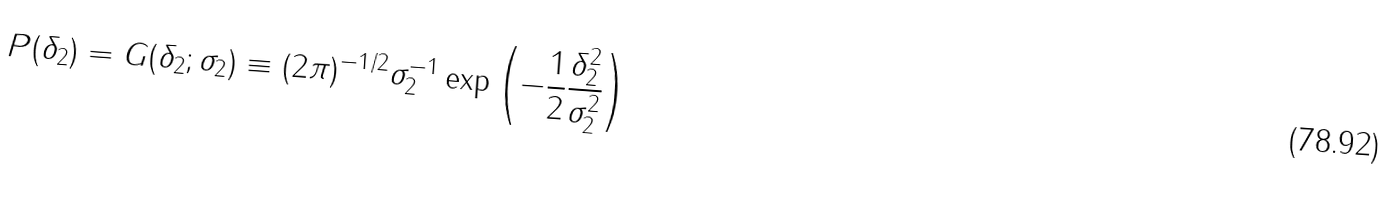<formula> <loc_0><loc_0><loc_500><loc_500>P ( \delta _ { 2 } ) = G ( \delta _ { 2 } ; \sigma _ { 2 } ) \equiv ( 2 \pi ) ^ { - 1 / 2 } \sigma _ { 2 } ^ { - 1 } \exp \left ( - \frac { 1 } { 2 } \frac { \delta _ { 2 } ^ { 2 } } { \sigma _ { 2 } ^ { 2 } } \right )</formula> 